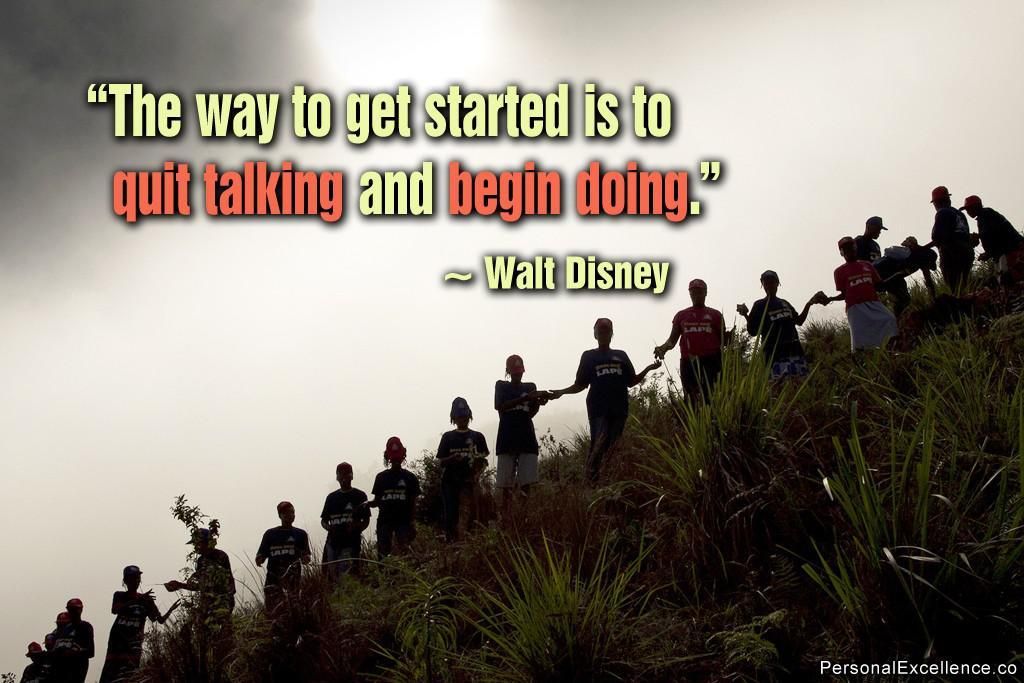<image>
Give a short and clear explanation of the subsequent image. "The way to get started is to quit talking and begin doing" reads the caption of this photo. 